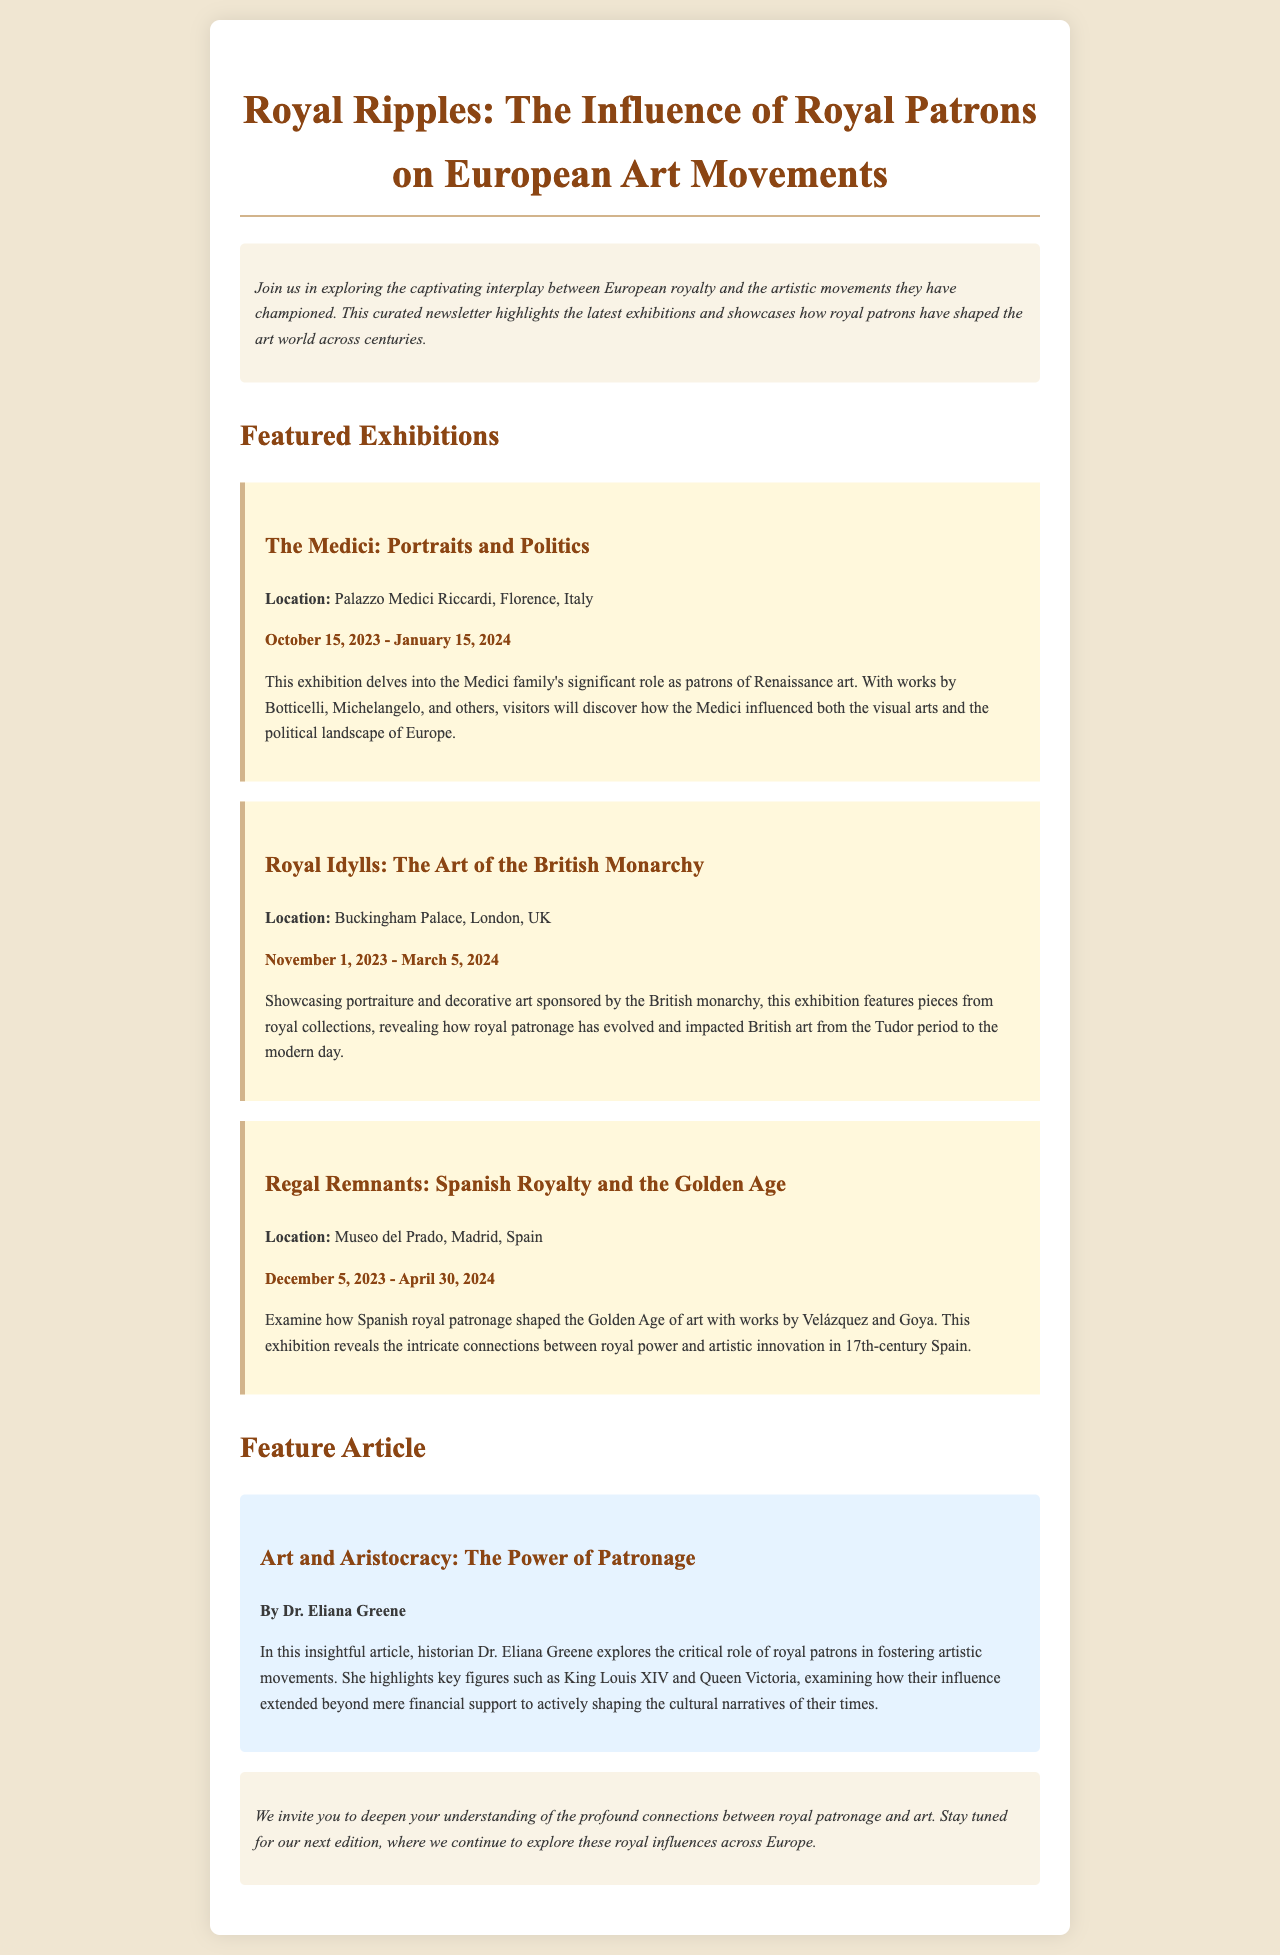what is the title of the newsletter? The title of the newsletter is prominently displayed at the top of the document.
Answer: Royal Ripples: The Influence of Royal Patrons on European Art Movements who authored the feature article? The document includes a specific mention of the author of the featured article on royal patronage.
Answer: Dr. Eliana Greene where is the exhibition "The Medici: Portraits and Politics" located? The location of the specific exhibition is stated in the exhibition section of the newsletter.
Answer: Palazzo Medici Riccardi, Florence, Italy when does the "Royal Idylls: The Art of the British Monarchy" exhibition run? The dates of the exhibition are specified to clarify its running period in the document.
Answer: November 1, 2023 - March 5, 2024 how does the newsletter encourage further engagement? The closing section of the document invites readers to take action based on the content.
Answer: Stay tuned for our next edition what time period does the "Regal Remnants: Spanish Royalty and the Golden Age" exhibition focus on? The document indicates the specific historical context addressed in the exhibition description.
Answer: 17th-century Spain what color is the background of the introduction section? The design specifications for the introduction section are outlined in the document's styles.
Answer: #f9f3e6 how many featured exhibitions are listed in the newsletter? A count of the exhibitions mentioned in the document provides this information.
Answer: Three 